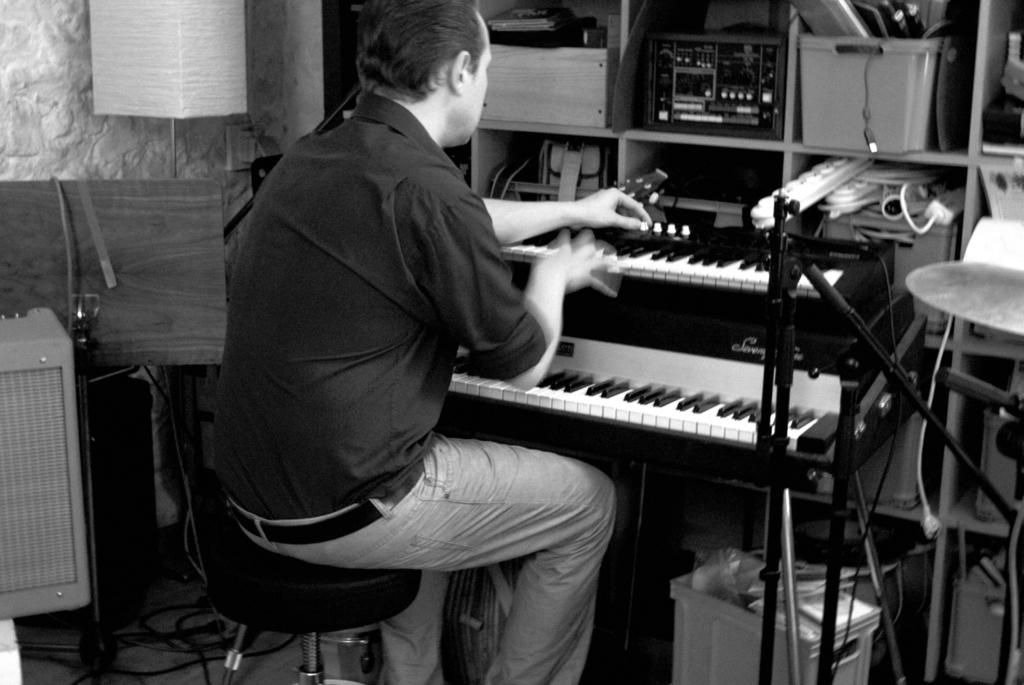What is the man in the image doing? The man is sitting on a stool and playing a piano. Where is the piano located in relation to the man? The piano is in front of the man. What can be seen on the shelf in the image? There is equipment placed on a shelf. What is visible in the background of the image? There is a lamp and a wall in the background. What type of spring can be seen in the image? There is no spring present in the image; it features a man playing a piano. 